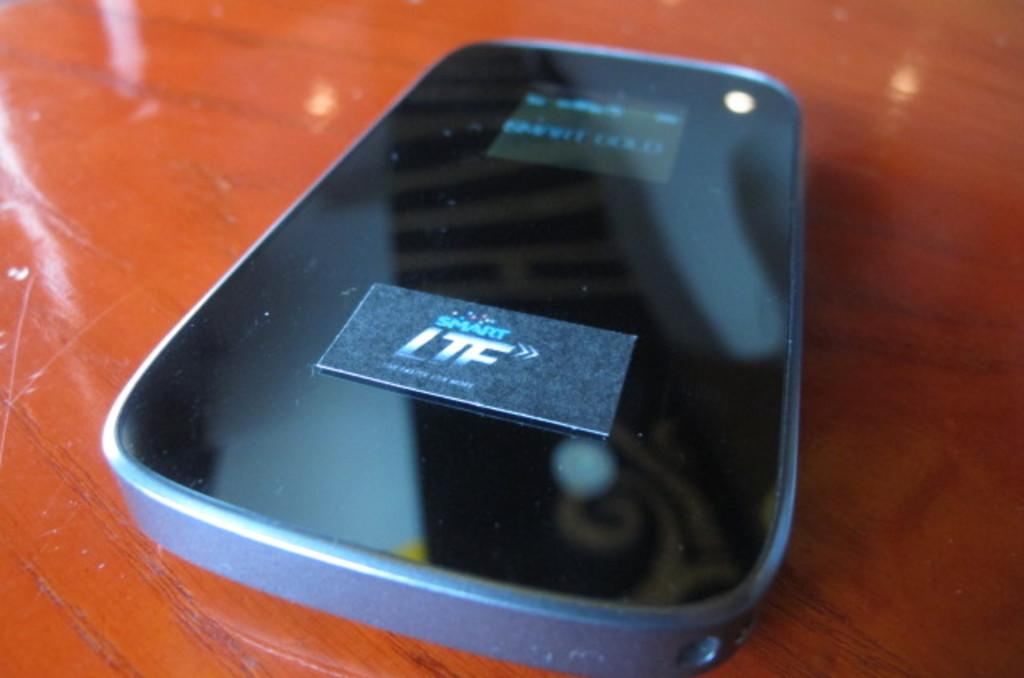<image>
Render a clear and concise summary of the photo. The back of a cellphone with the logo smart LTF. 